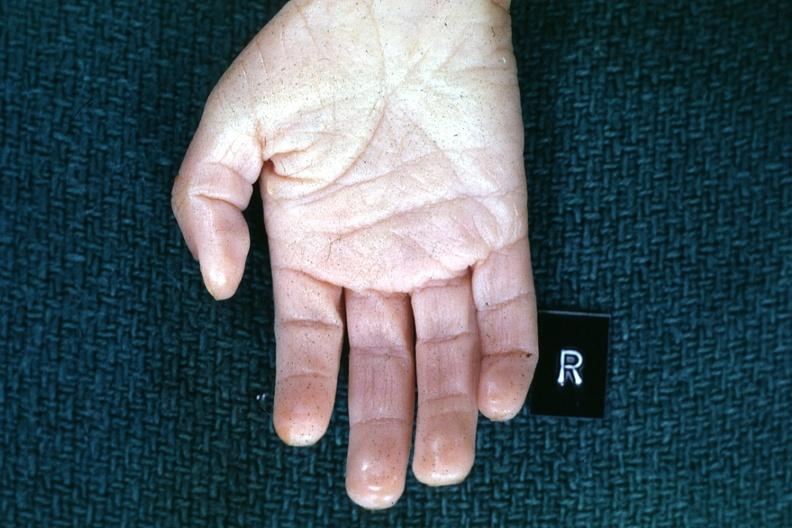what are present?
Answer the question using a single word or phrase. Extremities 